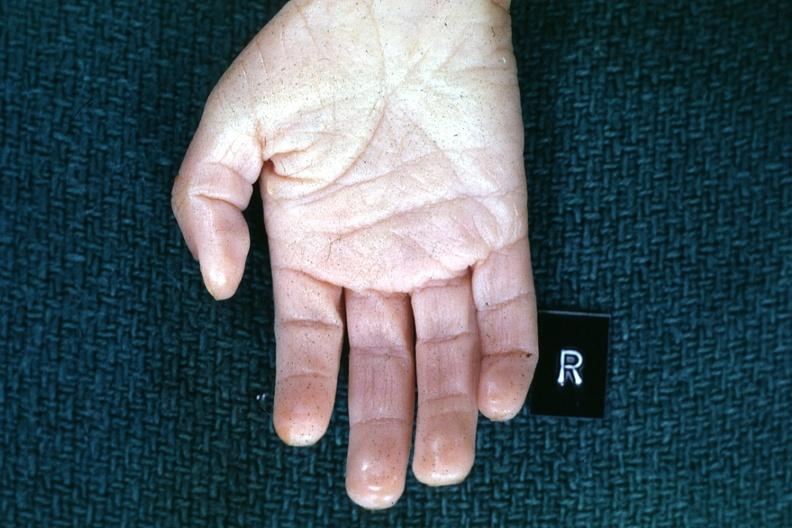what are present?
Answer the question using a single word or phrase. Extremities 